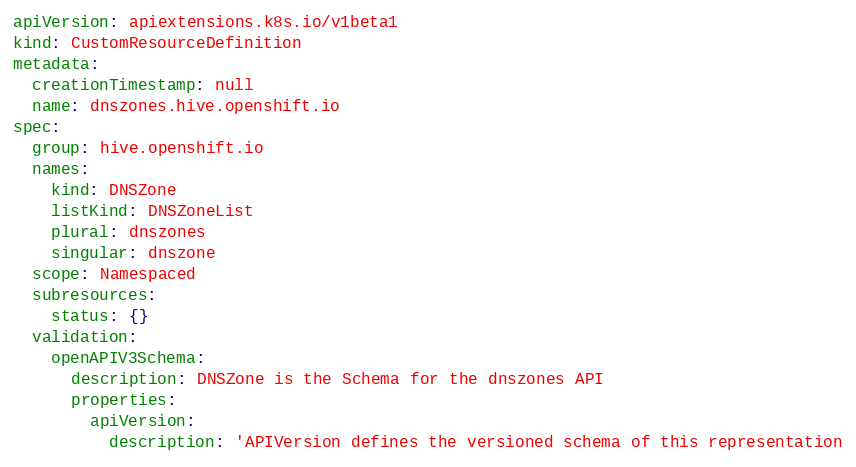<code> <loc_0><loc_0><loc_500><loc_500><_YAML_>apiVersion: apiextensions.k8s.io/v1beta1
kind: CustomResourceDefinition
metadata:
  creationTimestamp: null
  name: dnszones.hive.openshift.io
spec:
  group: hive.openshift.io
  names:
    kind: DNSZone
    listKind: DNSZoneList
    plural: dnszones
    singular: dnszone
  scope: Namespaced
  subresources:
    status: {}
  validation:
    openAPIV3Schema:
      description: DNSZone is the Schema for the dnszones API
      properties:
        apiVersion:
          description: 'APIVersion defines the versioned schema of this representation</code> 